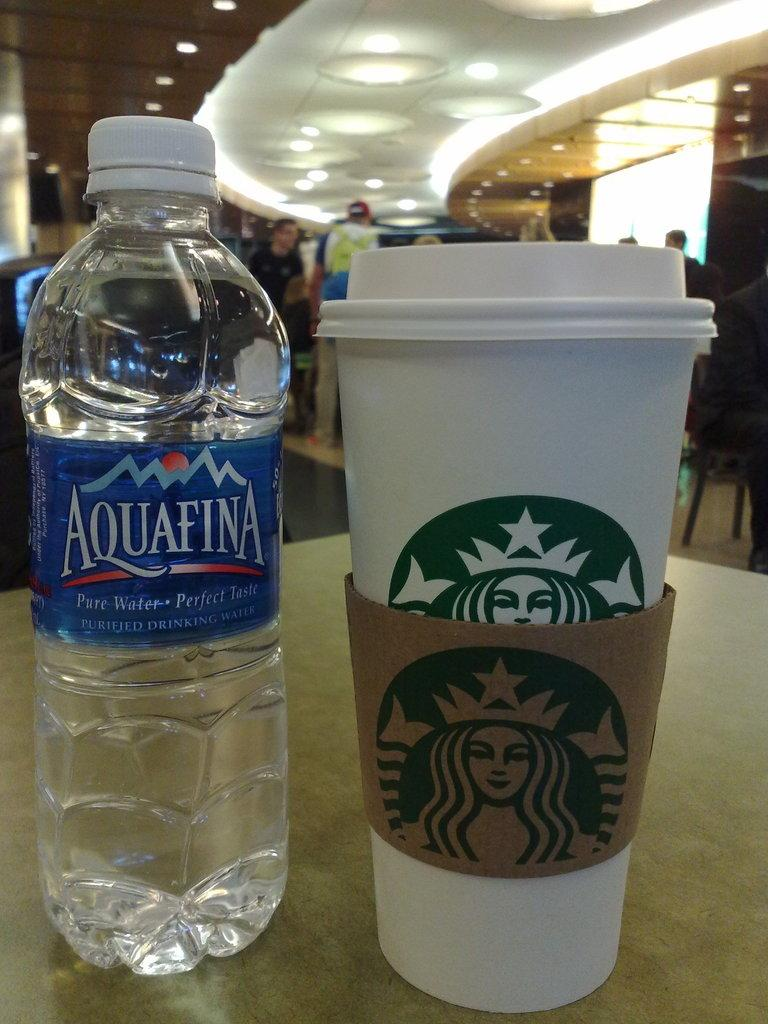<image>
Relay a brief, clear account of the picture shown. Starbucks coffee cup next to an Aquafina water bottle. 